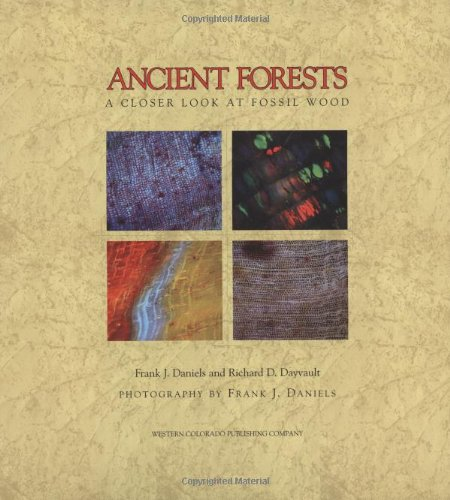Can you tell me about the significance of the different colors in the fossil wood shown in the cover images? The vibrant colors in the fossil wood, as seen on the book cover, result from the various minerals that have replaced the organic material over millions of years. Each color represents a different mineral, such as iron, copper, or silica, which imparts red, green, and blue hues respectively, providing clues about the environmental conditions when the wood was petrified. 